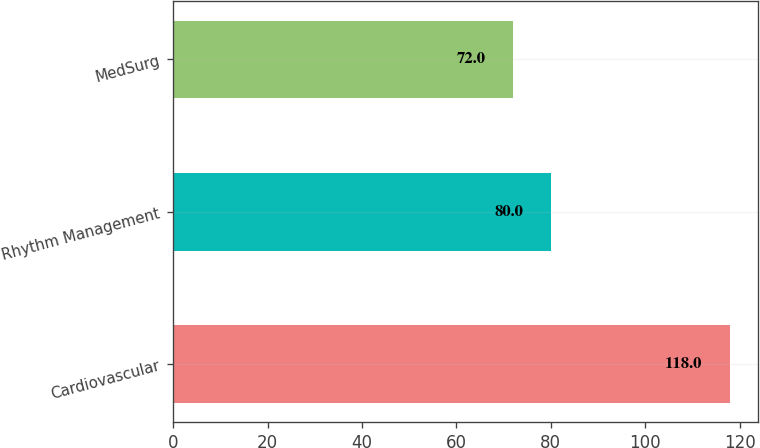<chart> <loc_0><loc_0><loc_500><loc_500><bar_chart><fcel>Cardiovascular<fcel>Rhythm Management<fcel>MedSurg<nl><fcel>118<fcel>80<fcel>72<nl></chart> 